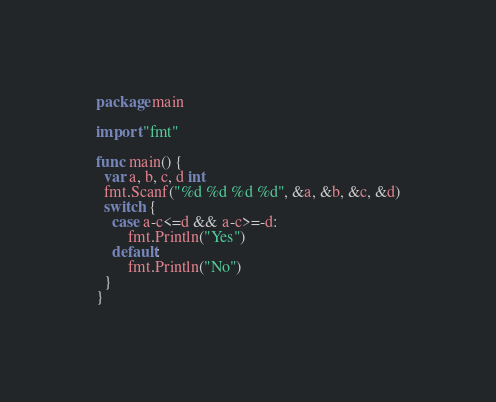Convert code to text. <code><loc_0><loc_0><loc_500><loc_500><_Go_>package main

import "fmt"

func main() {
  var a, b, c, d int
  fmt.Scanf("%d %d %d %d", &a, &b, &c, &d)
  switch {
    case a-c<=d && a-c>=-d:
    	fmt.Println("Yes")
    default:
    	fmt.Println("No")
  }
}</code> 